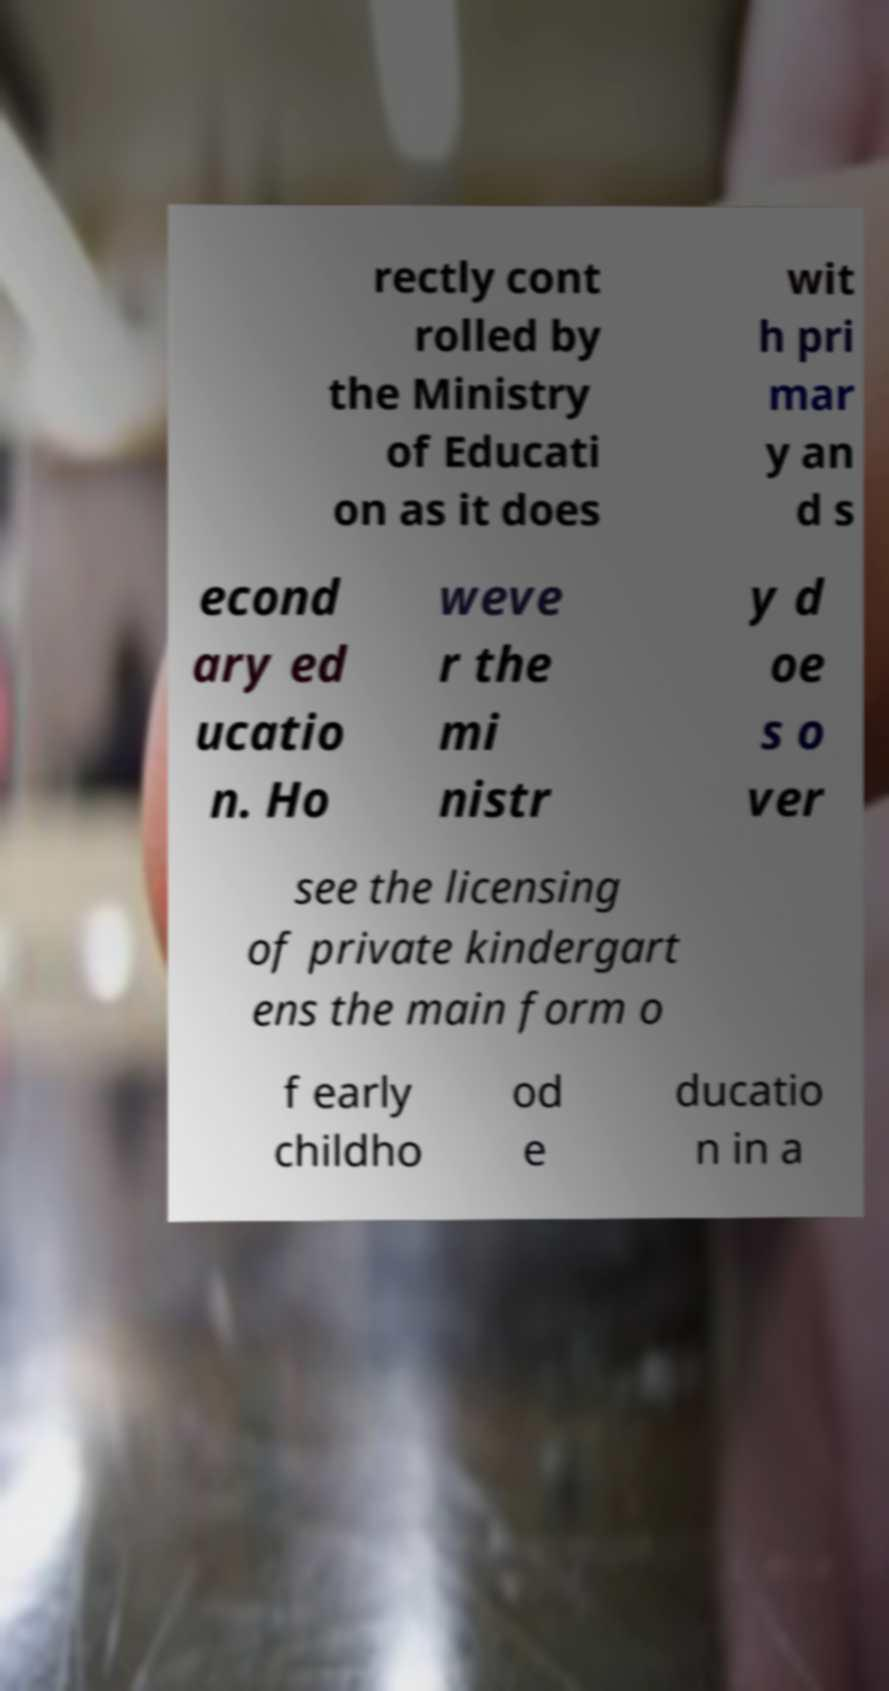There's text embedded in this image that I need extracted. Can you transcribe it verbatim? rectly cont rolled by the Ministry of Educati on as it does wit h pri mar y an d s econd ary ed ucatio n. Ho weve r the mi nistr y d oe s o ver see the licensing of private kindergart ens the main form o f early childho od e ducatio n in a 